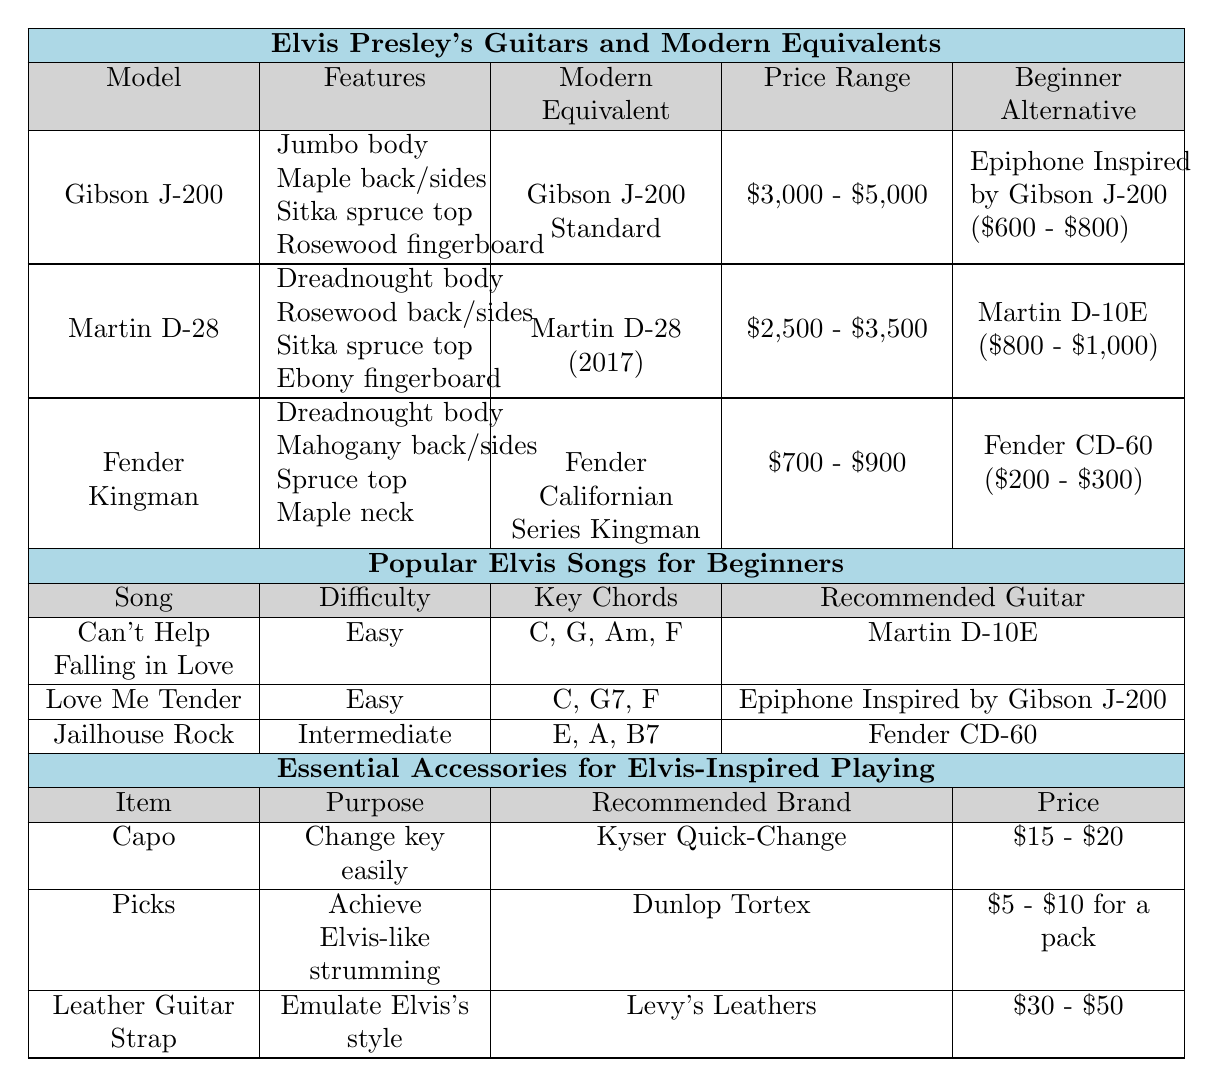What is the modern equivalent of Elvis Presley's Gibson J-200? The modern equivalent of Elvis Presley's Gibson J-200 is listed in the table as "Gibson J-200 Standard."
Answer: Gibson J-200 Standard Which beginner-friendly alternative guitar costs between $600 and $800? The table states that the beginner-friendly alternative for the Gibson J-200 is "Epiphone Inspired by Gibson J-200," and its price range is $600 - $800.
Answer: Epiphone Inspired by Gibson J-200 What are the key chords for "Can't Help Falling in Love"? The table shows that the key chords for "Can't Help Falling in Love" are C, G, Am, and F.
Answer: C, G, Am, F How much is the price range for Martin D-28? According to the table, the price range for Martin D-28 is between $2,500 and $3,500.
Answer: $2,500 - $3,500 Is the Fender CD-60 recommended for the song "Jailhouse Rock"? The table indicates that the recommended guitar for "Jailhouse Rock" is indeed the Fender CD-60, making the statement true.
Answer: Yes What is the purpose of a capo according to the table? The table specifies that the purpose of a capo is to "change key easily."
Answer: Change key easily What is the combined price range of beginner-friendly alternatives for all guitars listed? The beginner-friendly alternatives are: Epiphone Inspired by Gibson J-200 ($600 - $800), Martin D-10E ($800 - $1,000), and Fender CD-60 ($200 - $300). The combined range is $600 - $800 for Epiphone, $800 - $1,000 for Martin, and $200 - $300 for Fender. Thus, the overall range is $200 to $1,000.
Answer: $200 - $1,000 Which guitar has the highest price range? Looking at the table, the Gibson J-200 has the highest price range listed, which is $3,000 - $5,000.
Answer: Gibson J-200 What item is recommended for achieving Elvis-like strumming? The table states that "Picks" are recommended for achieving Elvis-like strumming.
Answer: Picks What is the price range for a leather guitar strap? The table indicates that the price range for a leather guitar strap is $30 - $50.
Answer: $30 - $50 What is the difference in price range between the Gibson J-200 and the Fender Kingman? The price range for Gibson J-200 is $3,000 - $5,000 and for Fender Kingman is $700 - $900. To find the difference, we calculate the upper limit of Gibson J-200 ($5,000) - lower limit of Fender Kingman ($700), which equals $4,300.
Answer: $4,300 